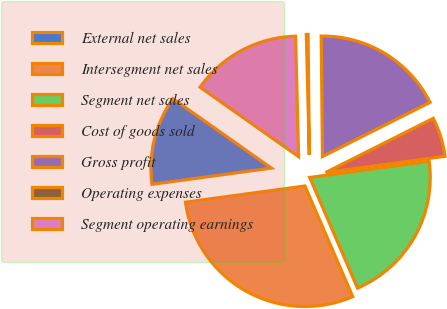<chart> <loc_0><loc_0><loc_500><loc_500><pie_chart><fcel>External net sales<fcel>Intersegment net sales<fcel>Segment net sales<fcel>Cost of goods sold<fcel>Gross profit<fcel>Operating expenses<fcel>Segment operating earnings<nl><fcel>11.92%<fcel>29.34%<fcel>20.66%<fcel>5.27%<fcel>17.74%<fcel>0.23%<fcel>14.83%<nl></chart> 